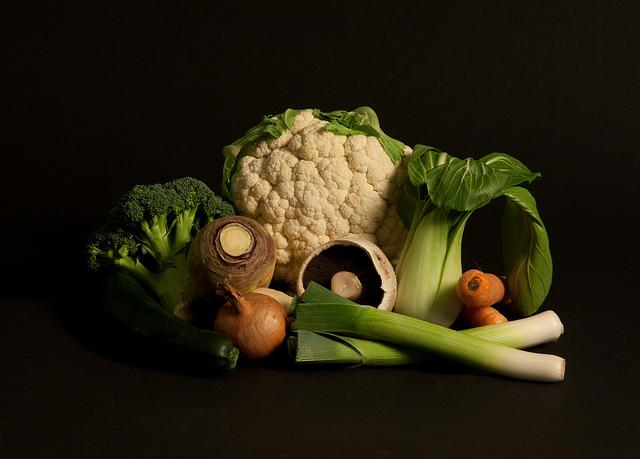Where can these foods be found? garden 